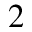<formula> <loc_0><loc_0><loc_500><loc_500>^ { 2 }</formula> 